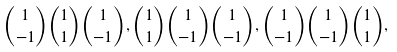<formula> <loc_0><loc_0><loc_500><loc_500>\binom { 1 } { - 1 } \binom { 1 } { 1 } \binom { 1 } { - 1 } , \binom { 1 } { 1 } \binom { 1 } { - 1 } \binom { 1 } { - 1 } , \binom { 1 } { - 1 } \binom { 1 } { - 1 } \binom { 1 } { 1 } ,</formula> 